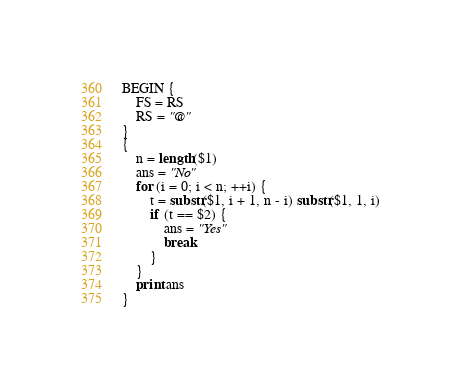Convert code to text. <code><loc_0><loc_0><loc_500><loc_500><_Awk_>BEGIN {
    FS = RS
    RS = "@"
}
{
    n = length($1)
    ans = "No"
    for (i = 0; i < n; ++i) {
        t = substr($1, i + 1, n - i) substr($1, 1, i)
        if (t == $2) {
            ans = "Yes"
            break
        }
    }
    print ans
}
</code> 